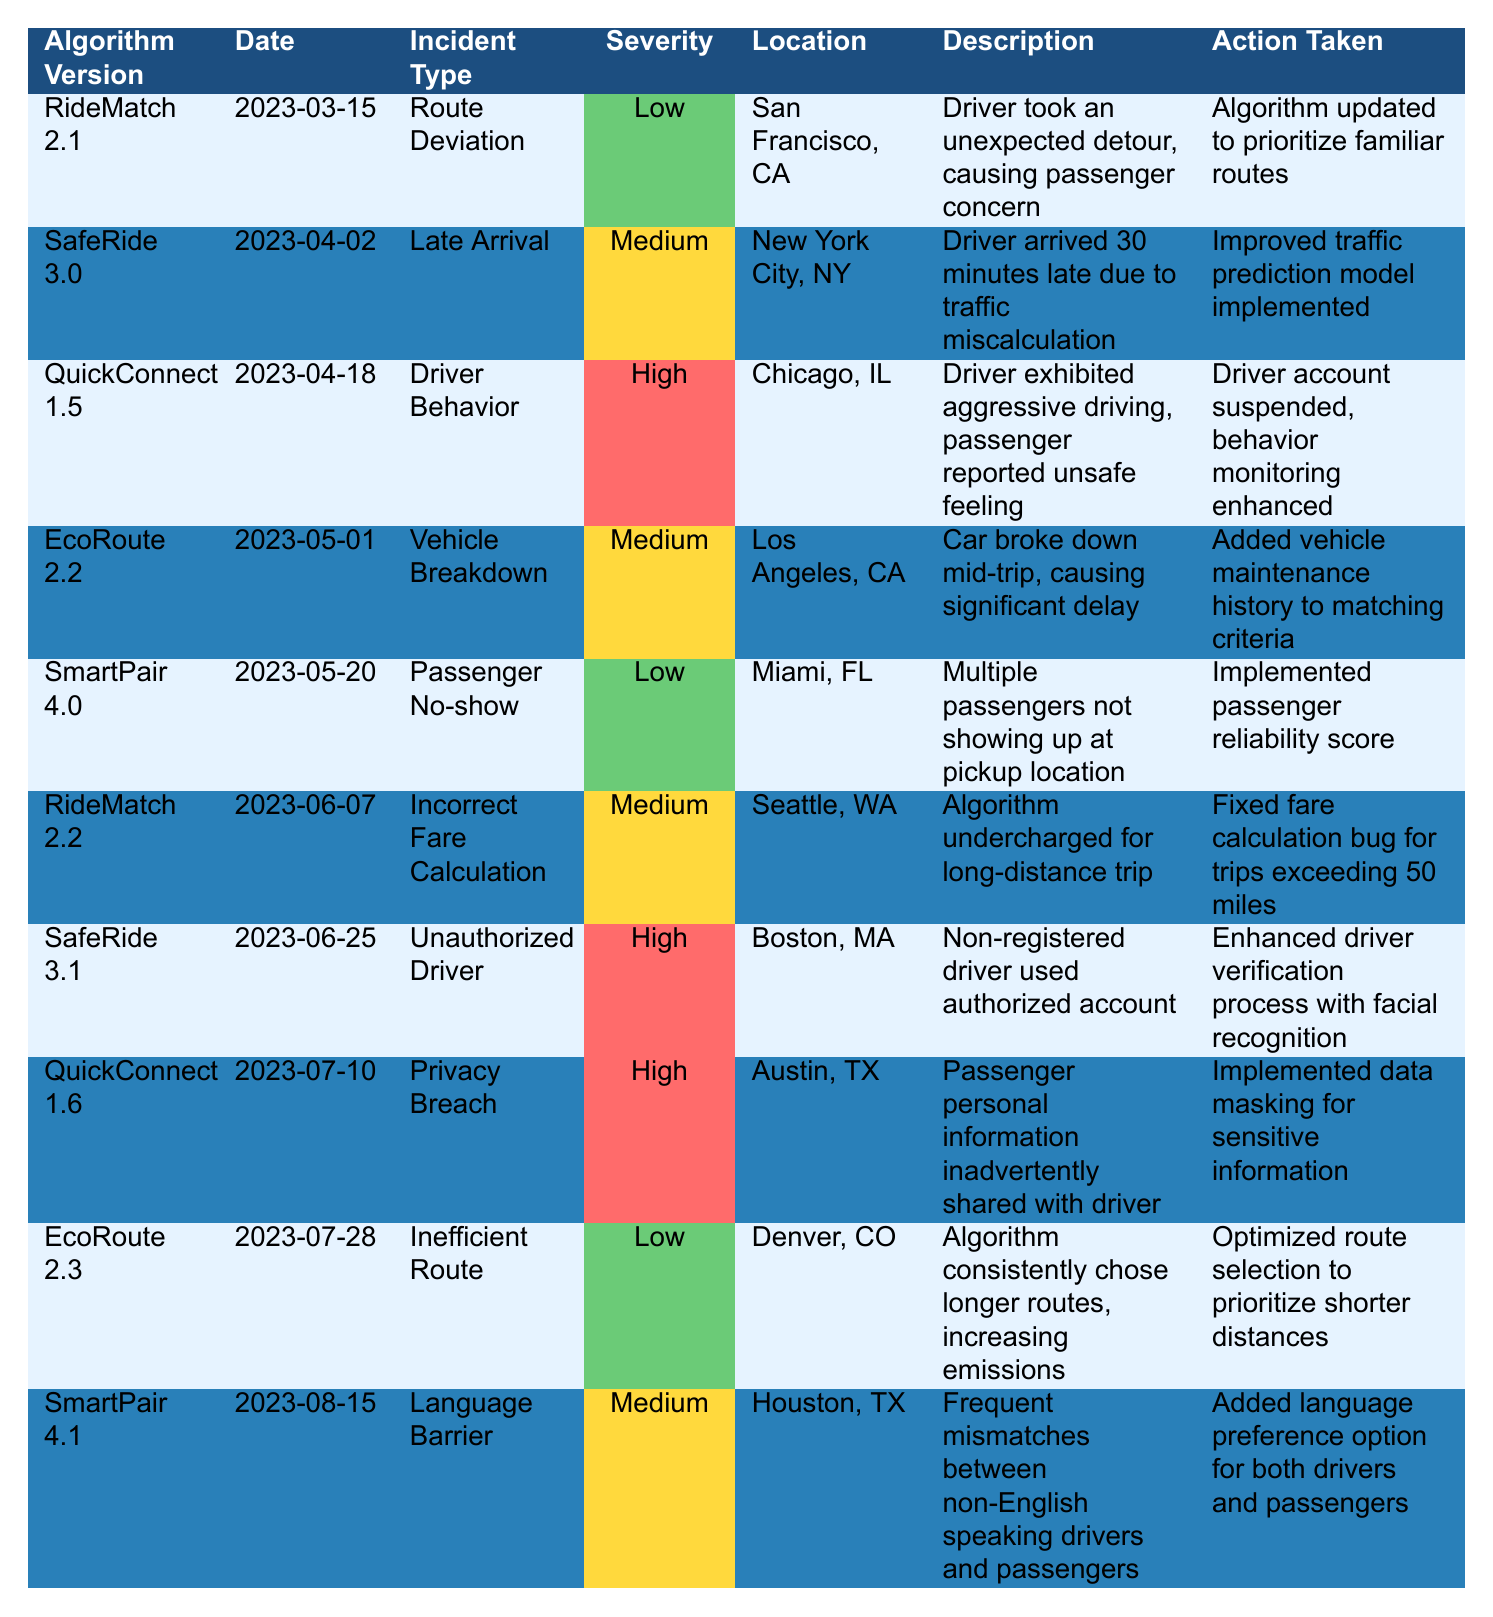What is the incident type reported on March 15, 2023? The table shows that on March 15, 2023, the incident type for the algorithm version RideMatch 2.1 is "Route Deviation."
Answer: Route Deviation How many incidents have a high severity rating? After reviewing the table, it shows three incidents with a high severity rating: "Driver Behavior" from QuickConnect 1.5, "Unauthorized Driver" from SafeRide 3.1, and "Privacy Breach" from QuickConnect 1.6.
Answer: 3 Which algorithm version had an action taken to enhance driver verification? The table indicates that SafeRide 3.1 took action to enhance driver verification with facial recognition in response to an "Unauthorized Driver" incident.
Answer: SafeRide 3.1 What was the date of the incident classified as "Late Arrival"? Referring to the table, the incident type "Late Arrival" occurred on April 2, 2023, under the algorithm version SafeRide 3.0.
Answer: April 2, 2023 Is there any incident that involved the action of optimizing route selection? Looking at the table, the incident for "Inefficient Route" under EcoRoute 2.3 involved optimizing route selection to prioritize shorter distances. Therefore, the answer is yes.
Answer: Yes How many incidents were reported in the city of Chicago? The table shows only one incident reported in Chicago, which is "Driver Behavior" under QuickConnect 1.5.
Answer: 1 What was the severity of the incident involving a vehicle breakdown? The table lists the severity of the "Vehicle Breakdown" incident under EcoRoute 2.2 as medium.
Answer: Medium Which incident types were reported in Los Angeles? From the table, the incident type reported in Los Angeles under EcoRoute 2.2 was "Vehicle Breakdown." There are no other incidents listed for that city.
Answer: Vehicle Breakdown What improvements were made to address the issue with incorrect fare calculation? According to the table, the action taken to address the incorrect fare calculation incident under RideMatch 2.2 was to fix a fare calculation bug for trips exceeding 50 miles.
Answer: Fixed fare calculation bug Which algorithm version had the highest number of safety-related incidents? Reviewing the table, both QuickConnect (versions 1.5 and 1.6) reported separately "Driver Behavior" and "Privacy Breach," both incidents relating to safety. However, if we account for incidents related to safety in other algorithms, SafeRide has reported the highest with two high-severity incidents.
Answer: QuickConnect and SafeRide (tie) What was the primary concern noted for the passengers in Miami? In Miami, the table reports a "Passenger No-show" incident under SmartPair 4.0, highlighting the concern of multiple passengers not showing up at the pickup location.
Answer: Passenger No-show What actions were taken for the "Language Barrier" incident? The table states that for the "Language Barrier" incident under SmartPair 4.1, the action taken was to add a language preference option for both drivers and passengers to reduce mismatches.
Answer: Added language preference option 